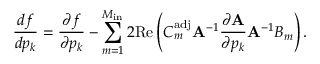Convert formula to latex. <formula><loc_0><loc_0><loc_500><loc_500>\frac { d f } { d p _ { k } } = \frac { \partial f } { \partial p _ { k } } - \sum _ { m = 1 } ^ { M _ { i n } } 2 R e \left ( C _ { m } ^ { a d j } A ^ { - 1 } \frac { \partial A } { \partial p _ { k } } A ^ { - 1 } B _ { m } \right ) .</formula> 